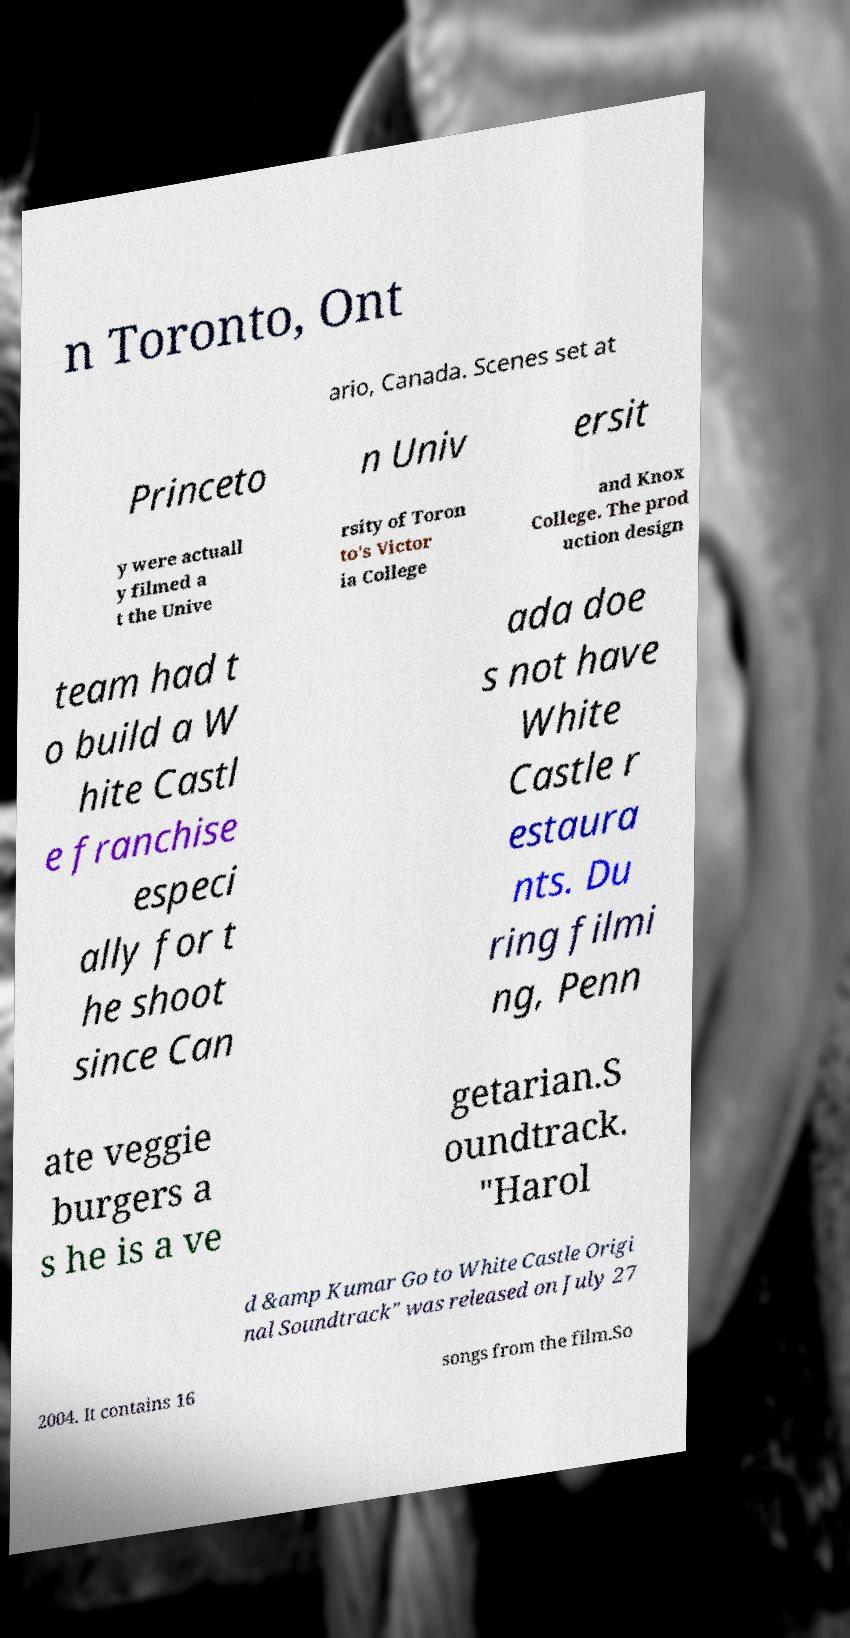Can you accurately transcribe the text from the provided image for me? n Toronto, Ont ario, Canada. Scenes set at Princeto n Univ ersit y were actuall y filmed a t the Unive rsity of Toron to's Victor ia College and Knox College. The prod uction design team had t o build a W hite Castl e franchise especi ally for t he shoot since Can ada doe s not have White Castle r estaura nts. Du ring filmi ng, Penn ate veggie burgers a s he is a ve getarian.S oundtrack. "Harol d &amp Kumar Go to White Castle Origi nal Soundtrack" was released on July 27 2004. It contains 16 songs from the film.So 